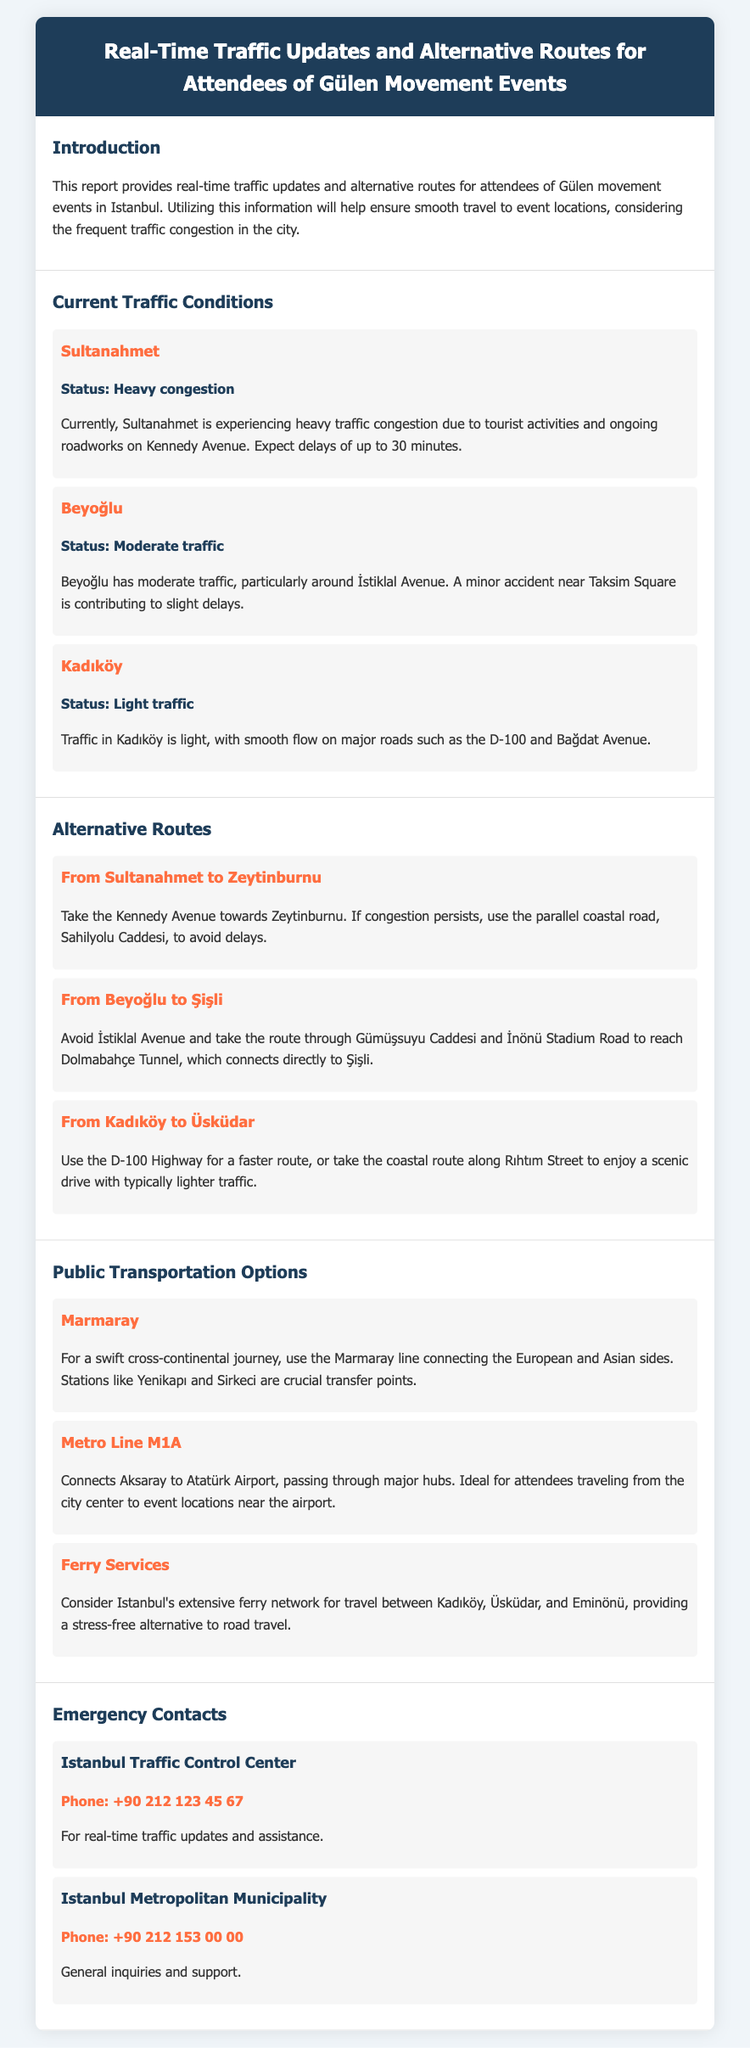what is the current traffic status in Sultanahmet? The document states that Sultanahmet is experiencing heavy congestion due to tourist activities and ongoing roadworks.
Answer: Heavy congestion how long can one expect delays in Sultanahmet? The report indicates that delays of up to 30 minutes can be expected in Sultanahmet due to heavy traffic.
Answer: 30 minutes what is the alternative route from Sultanahmet to Zeytinburnu? For the route from Sultanahmet to Zeytinburnu, the document suggests taking Kennedy Avenue or the coastal road Sahilyolu Caddesi.
Answer: Kennedy Avenue or Sahilyolu Caddesi which metro line is mentioned in the report? The report mentions the Metro Line M1A that connects Aksaray to Atatürk Airport.
Answer: Metro Line M1A what type of traffic condition is reported in Kadıköy? The document states that Kadıköy is experiencing light traffic, with smooth flow on major roads.
Answer: Light traffic who can be contacted for real-time traffic updates in Istanbul? The report provides the contact number for the Istanbul Traffic Control Center as a source for real-time updates.
Answer: +90 212 123 45 67 what mode of public transportation is described for a cross-continental journey? The document recommends using the Marmaray line for a swift cross-continental journey.
Answer: Marmaray what is the contact number for general inquiries at Istanbul Metropolitan Municipality? The report lists the Istanbul Metropolitan Municipality's contact number for general inquiries.
Answer: +90 212 153 00 00 